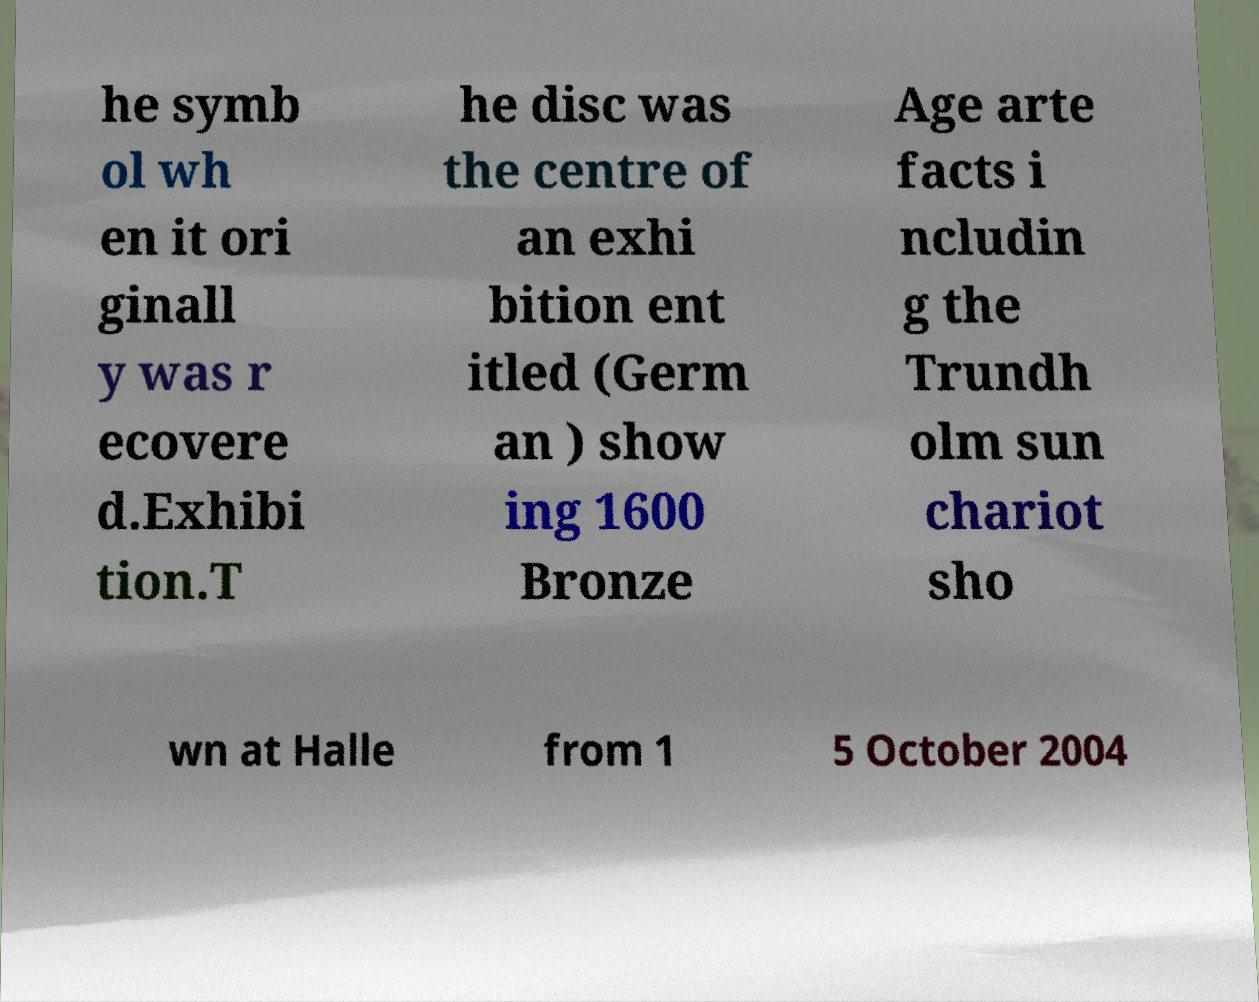Please identify and transcribe the text found in this image. he symb ol wh en it ori ginall y was r ecovere d.Exhibi tion.T he disc was the centre of an exhi bition ent itled (Germ an ) show ing 1600 Bronze Age arte facts i ncludin g the Trundh olm sun chariot sho wn at Halle from 1 5 October 2004 